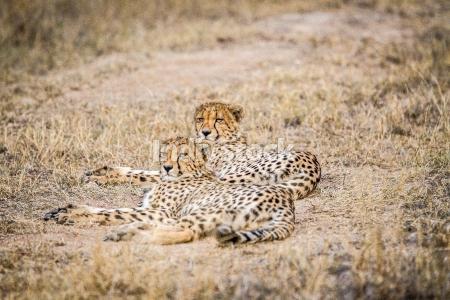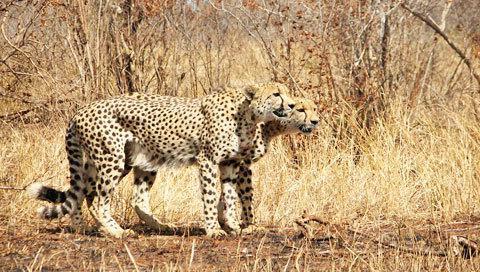The first image is the image on the left, the second image is the image on the right. Analyze the images presented: Is the assertion "There is a least one cheetah in each image peering out through the tall grass." valid? Answer yes or no. No. 